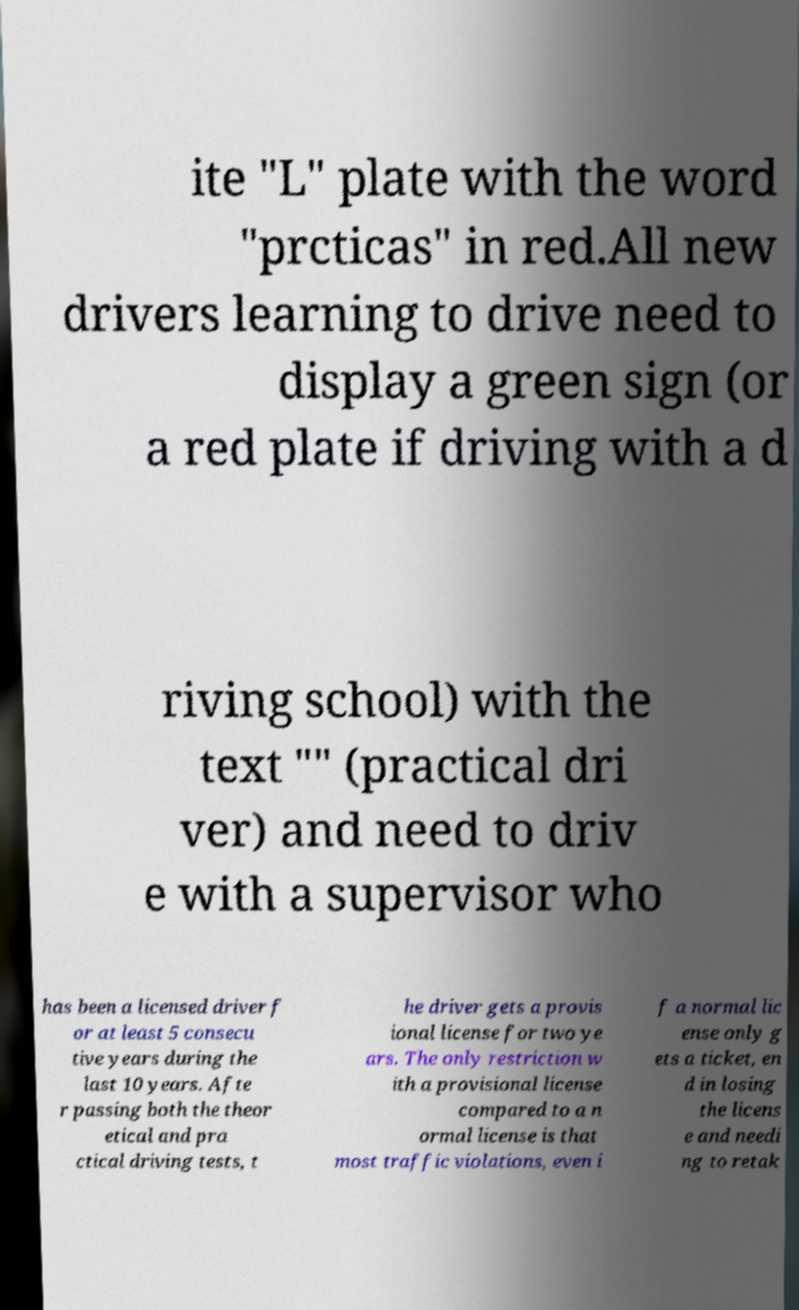Can you read and provide the text displayed in the image?This photo seems to have some interesting text. Can you extract and type it out for me? ite "L" plate with the word "prcticas" in red.All new drivers learning to drive need to display a green sign (or a red plate if driving with a d riving school) with the text "" (practical dri ver) and need to driv e with a supervisor who has been a licensed driver f or at least 5 consecu tive years during the last 10 years. Afte r passing both the theor etical and pra ctical driving tests, t he driver gets a provis ional license for two ye ars. The only restriction w ith a provisional license compared to a n ormal license is that most traffic violations, even i f a normal lic ense only g ets a ticket, en d in losing the licens e and needi ng to retak 